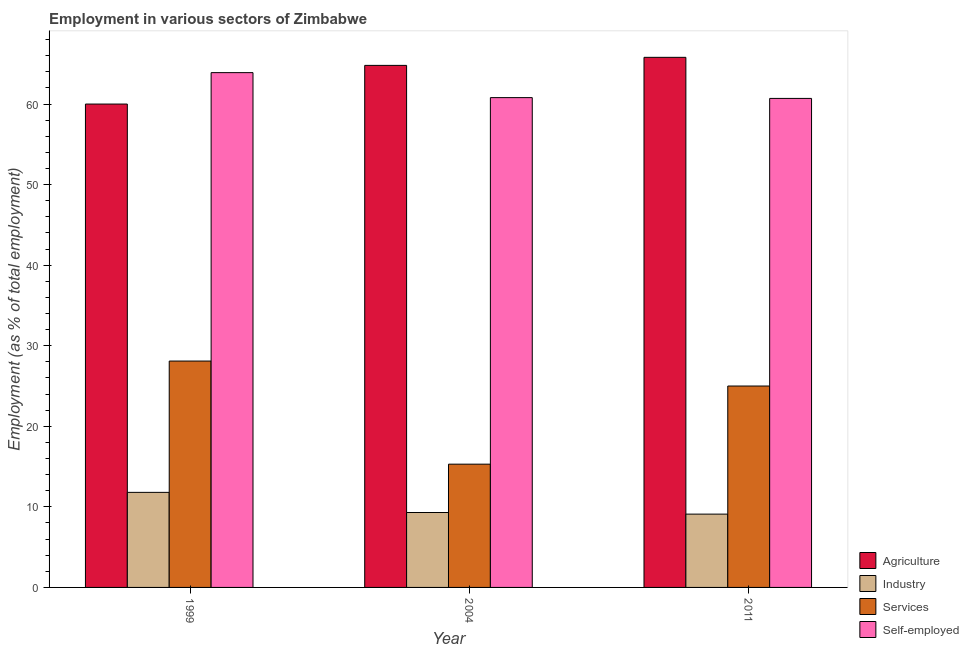How many different coloured bars are there?
Ensure brevity in your answer.  4. How many groups of bars are there?
Keep it short and to the point. 3. Are the number of bars on each tick of the X-axis equal?
Your answer should be very brief. Yes. How many bars are there on the 2nd tick from the left?
Keep it short and to the point. 4. How many bars are there on the 2nd tick from the right?
Ensure brevity in your answer.  4. What is the label of the 3rd group of bars from the left?
Offer a terse response. 2011. Across all years, what is the maximum percentage of workers in services?
Keep it short and to the point. 28.1. Across all years, what is the minimum percentage of self employed workers?
Your answer should be very brief. 60.7. What is the total percentage of workers in agriculture in the graph?
Your answer should be very brief. 190.6. What is the difference between the percentage of workers in agriculture in 1999 and that in 2011?
Ensure brevity in your answer.  -5.8. What is the difference between the percentage of workers in industry in 2004 and the percentage of workers in agriculture in 1999?
Make the answer very short. -2.5. What is the average percentage of self employed workers per year?
Make the answer very short. 61.8. In the year 1999, what is the difference between the percentage of workers in industry and percentage of workers in services?
Ensure brevity in your answer.  0. In how many years, is the percentage of workers in industry greater than 64 %?
Your response must be concise. 0. What is the ratio of the percentage of workers in services in 2004 to that in 2011?
Ensure brevity in your answer.  0.61. Is the percentage of workers in services in 1999 less than that in 2011?
Give a very brief answer. No. What is the difference between the highest and the second highest percentage of workers in industry?
Provide a short and direct response. 2.5. What is the difference between the highest and the lowest percentage of workers in industry?
Make the answer very short. 2.7. In how many years, is the percentage of workers in services greater than the average percentage of workers in services taken over all years?
Your answer should be very brief. 2. Is the sum of the percentage of self employed workers in 1999 and 2011 greater than the maximum percentage of workers in industry across all years?
Offer a terse response. Yes. Is it the case that in every year, the sum of the percentage of self employed workers and percentage of workers in industry is greater than the sum of percentage of workers in services and percentage of workers in agriculture?
Your answer should be compact. Yes. What does the 3rd bar from the left in 2004 represents?
Provide a succinct answer. Services. What does the 4th bar from the right in 1999 represents?
Your response must be concise. Agriculture. How many bars are there?
Offer a terse response. 12. What is the difference between two consecutive major ticks on the Y-axis?
Make the answer very short. 10. Does the graph contain any zero values?
Your response must be concise. No. Does the graph contain grids?
Provide a succinct answer. No. Where does the legend appear in the graph?
Your answer should be compact. Bottom right. How many legend labels are there?
Provide a short and direct response. 4. What is the title of the graph?
Your answer should be compact. Employment in various sectors of Zimbabwe. What is the label or title of the X-axis?
Provide a succinct answer. Year. What is the label or title of the Y-axis?
Your answer should be compact. Employment (as % of total employment). What is the Employment (as % of total employment) in Agriculture in 1999?
Your answer should be compact. 60. What is the Employment (as % of total employment) in Industry in 1999?
Offer a terse response. 11.8. What is the Employment (as % of total employment) in Services in 1999?
Provide a succinct answer. 28.1. What is the Employment (as % of total employment) in Self-employed in 1999?
Ensure brevity in your answer.  63.9. What is the Employment (as % of total employment) in Agriculture in 2004?
Offer a terse response. 64.8. What is the Employment (as % of total employment) in Industry in 2004?
Provide a succinct answer. 9.3. What is the Employment (as % of total employment) in Services in 2004?
Your answer should be very brief. 15.3. What is the Employment (as % of total employment) of Self-employed in 2004?
Your answer should be very brief. 60.8. What is the Employment (as % of total employment) in Agriculture in 2011?
Offer a very short reply. 65.8. What is the Employment (as % of total employment) of Industry in 2011?
Make the answer very short. 9.1. What is the Employment (as % of total employment) of Services in 2011?
Your answer should be very brief. 25. What is the Employment (as % of total employment) in Self-employed in 2011?
Keep it short and to the point. 60.7. Across all years, what is the maximum Employment (as % of total employment) of Agriculture?
Your answer should be very brief. 65.8. Across all years, what is the maximum Employment (as % of total employment) in Industry?
Offer a terse response. 11.8. Across all years, what is the maximum Employment (as % of total employment) of Services?
Your response must be concise. 28.1. Across all years, what is the maximum Employment (as % of total employment) of Self-employed?
Your response must be concise. 63.9. Across all years, what is the minimum Employment (as % of total employment) of Agriculture?
Your answer should be very brief. 60. Across all years, what is the minimum Employment (as % of total employment) in Industry?
Your answer should be compact. 9.1. Across all years, what is the minimum Employment (as % of total employment) in Services?
Make the answer very short. 15.3. Across all years, what is the minimum Employment (as % of total employment) of Self-employed?
Your answer should be very brief. 60.7. What is the total Employment (as % of total employment) of Agriculture in the graph?
Your answer should be compact. 190.6. What is the total Employment (as % of total employment) in Industry in the graph?
Your answer should be very brief. 30.2. What is the total Employment (as % of total employment) in Services in the graph?
Provide a succinct answer. 68.4. What is the total Employment (as % of total employment) of Self-employed in the graph?
Provide a succinct answer. 185.4. What is the difference between the Employment (as % of total employment) of Industry in 1999 and that in 2004?
Your answer should be very brief. 2.5. What is the difference between the Employment (as % of total employment) in Services in 1999 and that in 2004?
Your answer should be very brief. 12.8. What is the difference between the Employment (as % of total employment) of Agriculture in 1999 and that in 2011?
Your answer should be very brief. -5.8. What is the difference between the Employment (as % of total employment) of Self-employed in 1999 and that in 2011?
Provide a short and direct response. 3.2. What is the difference between the Employment (as % of total employment) in Industry in 2004 and that in 2011?
Keep it short and to the point. 0.2. What is the difference between the Employment (as % of total employment) of Services in 2004 and that in 2011?
Offer a terse response. -9.7. What is the difference between the Employment (as % of total employment) in Self-employed in 2004 and that in 2011?
Your answer should be compact. 0.1. What is the difference between the Employment (as % of total employment) in Agriculture in 1999 and the Employment (as % of total employment) in Industry in 2004?
Make the answer very short. 50.7. What is the difference between the Employment (as % of total employment) in Agriculture in 1999 and the Employment (as % of total employment) in Services in 2004?
Offer a very short reply. 44.7. What is the difference between the Employment (as % of total employment) of Industry in 1999 and the Employment (as % of total employment) of Services in 2004?
Offer a very short reply. -3.5. What is the difference between the Employment (as % of total employment) in Industry in 1999 and the Employment (as % of total employment) in Self-employed in 2004?
Your answer should be compact. -49. What is the difference between the Employment (as % of total employment) in Services in 1999 and the Employment (as % of total employment) in Self-employed in 2004?
Your answer should be compact. -32.7. What is the difference between the Employment (as % of total employment) of Agriculture in 1999 and the Employment (as % of total employment) of Industry in 2011?
Give a very brief answer. 50.9. What is the difference between the Employment (as % of total employment) in Agriculture in 1999 and the Employment (as % of total employment) in Services in 2011?
Offer a terse response. 35. What is the difference between the Employment (as % of total employment) of Agriculture in 1999 and the Employment (as % of total employment) of Self-employed in 2011?
Make the answer very short. -0.7. What is the difference between the Employment (as % of total employment) of Industry in 1999 and the Employment (as % of total employment) of Self-employed in 2011?
Provide a short and direct response. -48.9. What is the difference between the Employment (as % of total employment) of Services in 1999 and the Employment (as % of total employment) of Self-employed in 2011?
Keep it short and to the point. -32.6. What is the difference between the Employment (as % of total employment) in Agriculture in 2004 and the Employment (as % of total employment) in Industry in 2011?
Your response must be concise. 55.7. What is the difference between the Employment (as % of total employment) in Agriculture in 2004 and the Employment (as % of total employment) in Services in 2011?
Provide a short and direct response. 39.8. What is the difference between the Employment (as % of total employment) in Industry in 2004 and the Employment (as % of total employment) in Services in 2011?
Offer a very short reply. -15.7. What is the difference between the Employment (as % of total employment) of Industry in 2004 and the Employment (as % of total employment) of Self-employed in 2011?
Ensure brevity in your answer.  -51.4. What is the difference between the Employment (as % of total employment) in Services in 2004 and the Employment (as % of total employment) in Self-employed in 2011?
Ensure brevity in your answer.  -45.4. What is the average Employment (as % of total employment) of Agriculture per year?
Give a very brief answer. 63.53. What is the average Employment (as % of total employment) of Industry per year?
Your response must be concise. 10.07. What is the average Employment (as % of total employment) in Services per year?
Offer a terse response. 22.8. What is the average Employment (as % of total employment) of Self-employed per year?
Provide a succinct answer. 61.8. In the year 1999, what is the difference between the Employment (as % of total employment) of Agriculture and Employment (as % of total employment) of Industry?
Your answer should be compact. 48.2. In the year 1999, what is the difference between the Employment (as % of total employment) of Agriculture and Employment (as % of total employment) of Services?
Your answer should be compact. 31.9. In the year 1999, what is the difference between the Employment (as % of total employment) of Agriculture and Employment (as % of total employment) of Self-employed?
Offer a terse response. -3.9. In the year 1999, what is the difference between the Employment (as % of total employment) of Industry and Employment (as % of total employment) of Services?
Your answer should be very brief. -16.3. In the year 1999, what is the difference between the Employment (as % of total employment) of Industry and Employment (as % of total employment) of Self-employed?
Offer a very short reply. -52.1. In the year 1999, what is the difference between the Employment (as % of total employment) of Services and Employment (as % of total employment) of Self-employed?
Your answer should be very brief. -35.8. In the year 2004, what is the difference between the Employment (as % of total employment) in Agriculture and Employment (as % of total employment) in Industry?
Provide a short and direct response. 55.5. In the year 2004, what is the difference between the Employment (as % of total employment) in Agriculture and Employment (as % of total employment) in Services?
Your answer should be compact. 49.5. In the year 2004, what is the difference between the Employment (as % of total employment) of Industry and Employment (as % of total employment) of Self-employed?
Provide a short and direct response. -51.5. In the year 2004, what is the difference between the Employment (as % of total employment) of Services and Employment (as % of total employment) of Self-employed?
Your answer should be very brief. -45.5. In the year 2011, what is the difference between the Employment (as % of total employment) in Agriculture and Employment (as % of total employment) in Industry?
Offer a terse response. 56.7. In the year 2011, what is the difference between the Employment (as % of total employment) in Agriculture and Employment (as % of total employment) in Services?
Keep it short and to the point. 40.8. In the year 2011, what is the difference between the Employment (as % of total employment) of Industry and Employment (as % of total employment) of Services?
Give a very brief answer. -15.9. In the year 2011, what is the difference between the Employment (as % of total employment) of Industry and Employment (as % of total employment) of Self-employed?
Make the answer very short. -51.6. In the year 2011, what is the difference between the Employment (as % of total employment) of Services and Employment (as % of total employment) of Self-employed?
Make the answer very short. -35.7. What is the ratio of the Employment (as % of total employment) in Agriculture in 1999 to that in 2004?
Provide a succinct answer. 0.93. What is the ratio of the Employment (as % of total employment) in Industry in 1999 to that in 2004?
Provide a succinct answer. 1.27. What is the ratio of the Employment (as % of total employment) of Services in 1999 to that in 2004?
Provide a succinct answer. 1.84. What is the ratio of the Employment (as % of total employment) of Self-employed in 1999 to that in 2004?
Make the answer very short. 1.05. What is the ratio of the Employment (as % of total employment) in Agriculture in 1999 to that in 2011?
Make the answer very short. 0.91. What is the ratio of the Employment (as % of total employment) of Industry in 1999 to that in 2011?
Offer a very short reply. 1.3. What is the ratio of the Employment (as % of total employment) of Services in 1999 to that in 2011?
Give a very brief answer. 1.12. What is the ratio of the Employment (as % of total employment) of Self-employed in 1999 to that in 2011?
Your answer should be very brief. 1.05. What is the ratio of the Employment (as % of total employment) of Industry in 2004 to that in 2011?
Make the answer very short. 1.02. What is the ratio of the Employment (as % of total employment) of Services in 2004 to that in 2011?
Make the answer very short. 0.61. What is the ratio of the Employment (as % of total employment) in Self-employed in 2004 to that in 2011?
Your answer should be very brief. 1. What is the difference between the highest and the second highest Employment (as % of total employment) in Agriculture?
Ensure brevity in your answer.  1. What is the difference between the highest and the second highest Employment (as % of total employment) of Services?
Make the answer very short. 3.1. What is the difference between the highest and the lowest Employment (as % of total employment) of Services?
Keep it short and to the point. 12.8. 